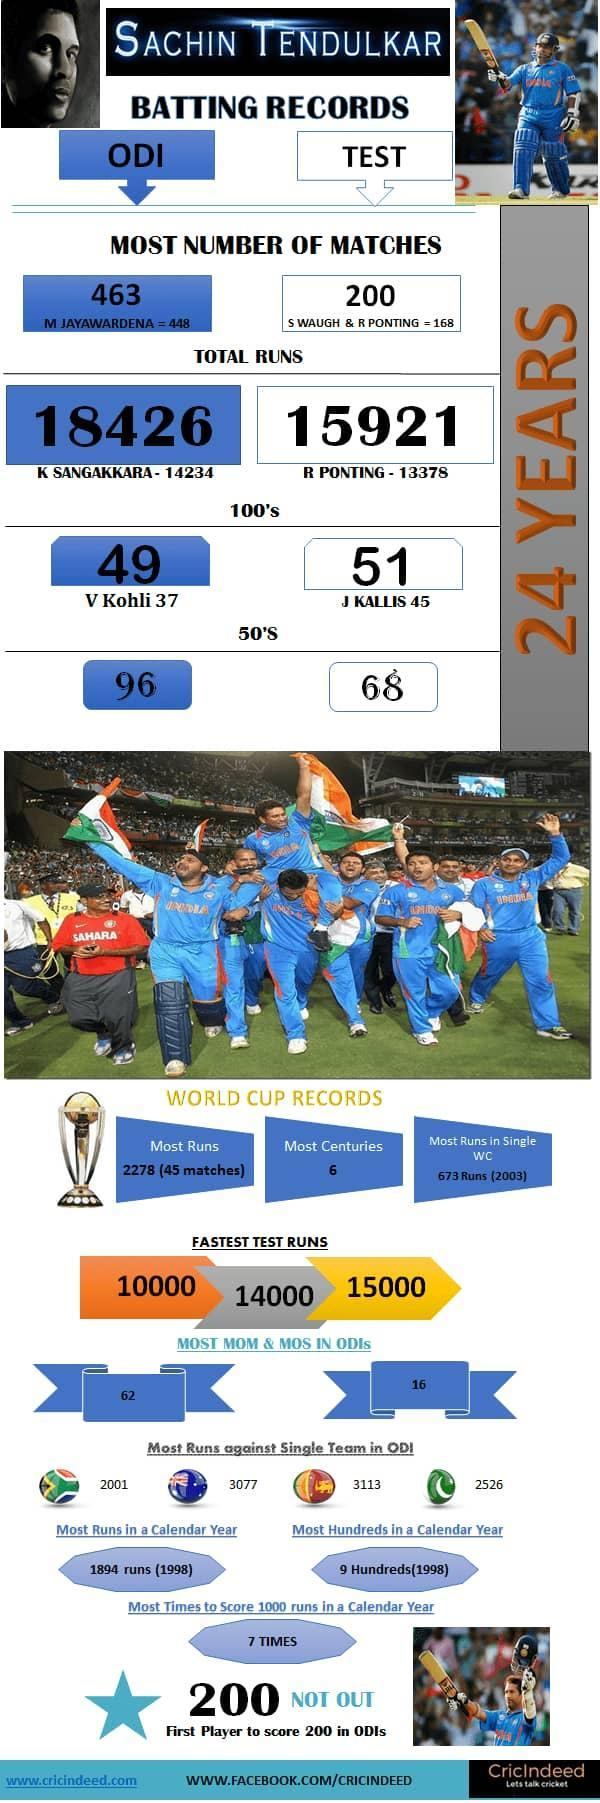Which is the second-highest total run in test matches?
Answer the question with a short phrase. 13378 Who has the second-highest number of 100's in ODI matches? V Kohli Who has the second-highest total runs in ODI matches? K Sangakkara Who has the second-highest total runs in test matches? R Ponting Which is the second-highest total run in ODI matches? 14234 Who has the second-highest number of 100's in test matches? J Kallis Who has the second-highest number of ODI matches? M Jayawardena Who has the second-highest number of test matches? S Waugh & R Ponting 